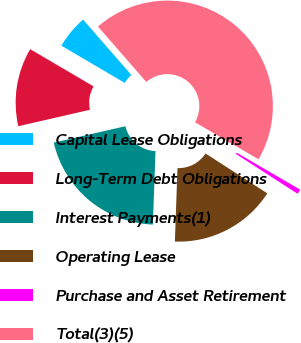<chart> <loc_0><loc_0><loc_500><loc_500><pie_chart><fcel>Capital Lease Obligations<fcel>Long-Term Debt Obligations<fcel>Interest Payments(1)<fcel>Operating Lease<fcel>Purchase and Asset Retirement<fcel>Total(3)(5)<nl><fcel>5.14%<fcel>12.04%<fcel>20.85%<fcel>16.44%<fcel>0.73%<fcel>44.8%<nl></chart> 